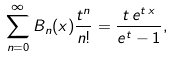Convert formula to latex. <formula><loc_0><loc_0><loc_500><loc_500>\sum _ { n = 0 } ^ { \infty } B _ { n } ( x ) \frac { t ^ { n } } { n ! } = \frac { t \, e ^ { t \, x } } { e ^ { t } - 1 } ,</formula> 